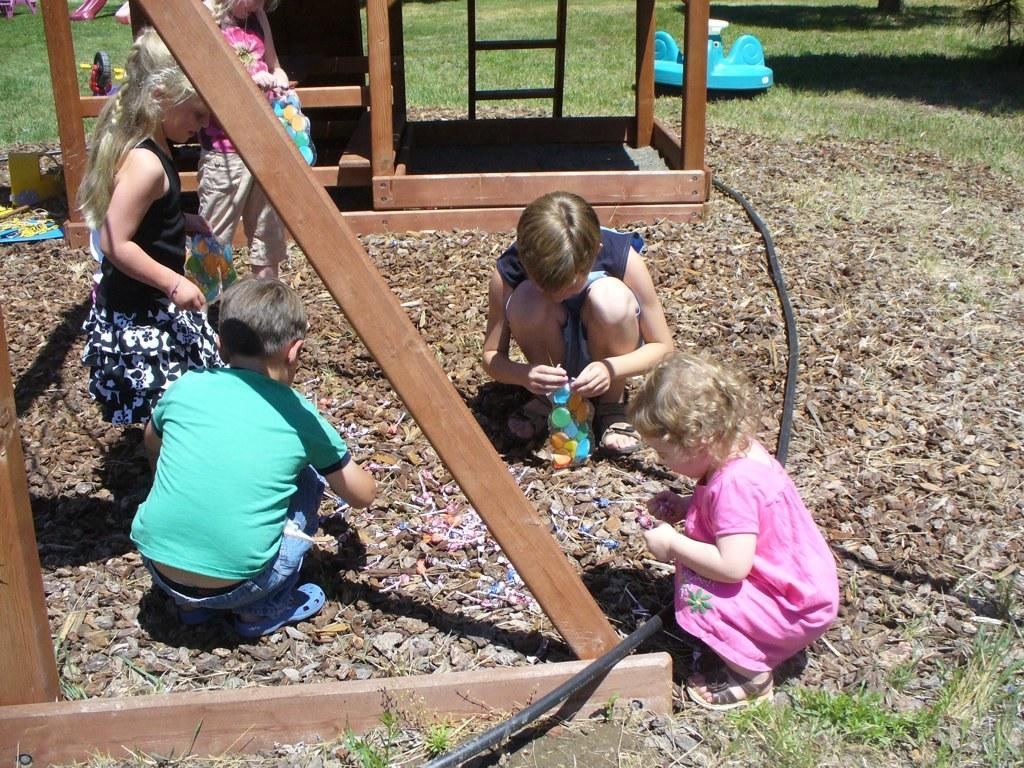Who is present in the image? There are children in the image. What is the terrain like in the image? The land is covered with rocks. What are the children holding in the image? The children are holding objects. Can you describe the toy in the image? There is a toy above the grass in the image. What else can be seen in the image besides the children and the toy? There are rods in the image. What type of knowledge can be gained from the goldfish in the image? There are no goldfish present in the image, so no knowledge can be gained from them. 